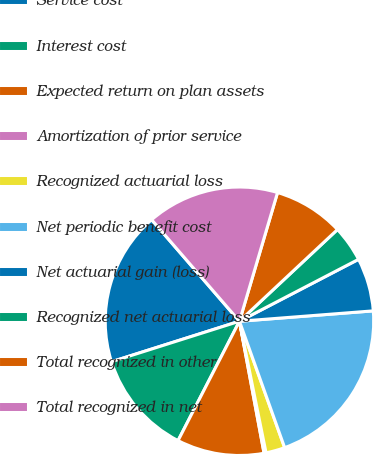Convert chart. <chart><loc_0><loc_0><loc_500><loc_500><pie_chart><fcel>Service cost<fcel>Interest cost<fcel>Expected return on plan assets<fcel>Amortization of prior service<fcel>Recognized actuarial loss<fcel>Net periodic benefit cost<fcel>Net actuarial gain (loss)<fcel>Recognized net actuarial loss<fcel>Total recognized in other<fcel>Total recognized in net<nl><fcel>18.53%<fcel>12.56%<fcel>10.5%<fcel>0.24%<fcel>2.29%<fcel>20.77%<fcel>6.4%<fcel>4.34%<fcel>8.45%<fcel>15.93%<nl></chart> 